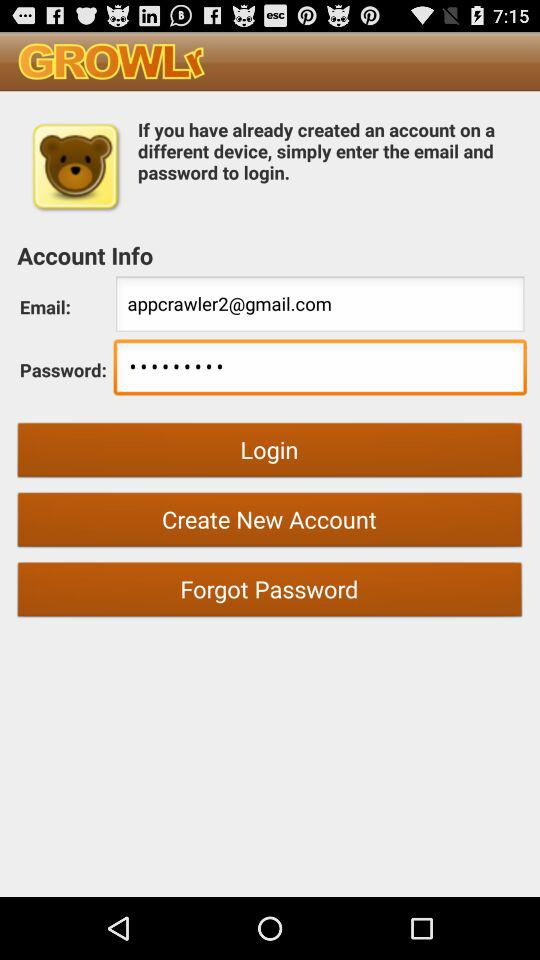What is the app name? The app name is "GROWLr". 